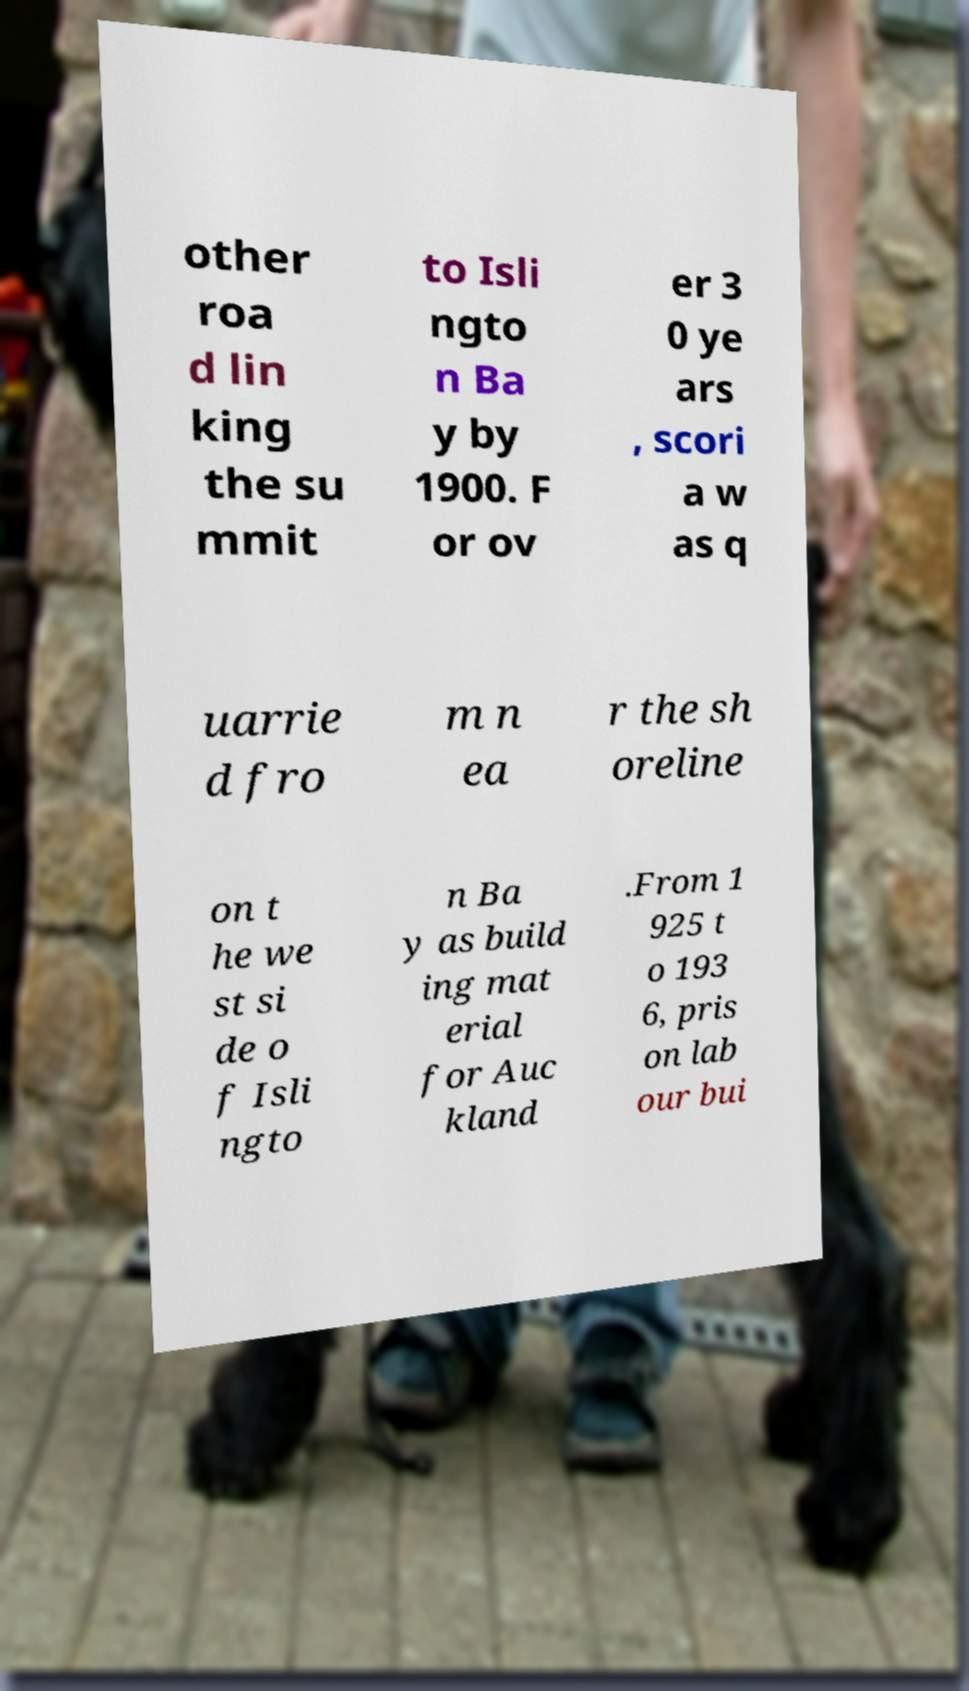For documentation purposes, I need the text within this image transcribed. Could you provide that? other roa d lin king the su mmit to Isli ngto n Ba y by 1900. F or ov er 3 0 ye ars , scori a w as q uarrie d fro m n ea r the sh oreline on t he we st si de o f Isli ngto n Ba y as build ing mat erial for Auc kland .From 1 925 t o 193 6, pris on lab our bui 